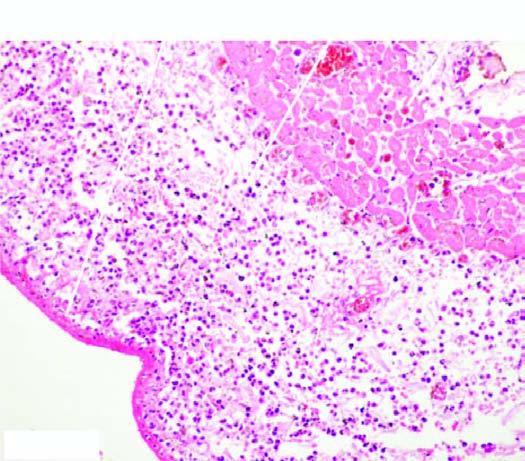s the epidermis covered with pink serofibrinous exudates?
Answer the question using a single word or phrase. No 